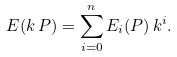<formula> <loc_0><loc_0><loc_500><loc_500>\L E ( k \, P ) = \sum _ { i = 0 } ^ { n } \L E _ { i } ( P ) \, k ^ { i } .</formula> 